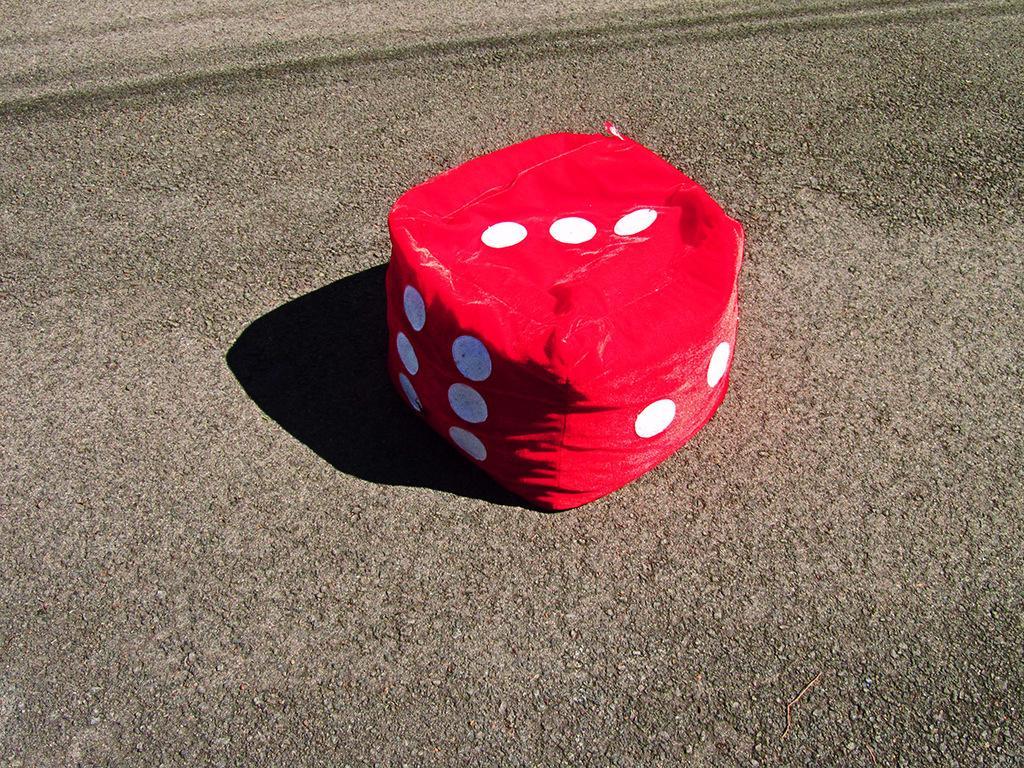Please provide a concise description of this image. This image is taken outdoors. At the bottom of the image there is a road. In the middle of the image there is a dice made of a cloth with a few dots on it. 